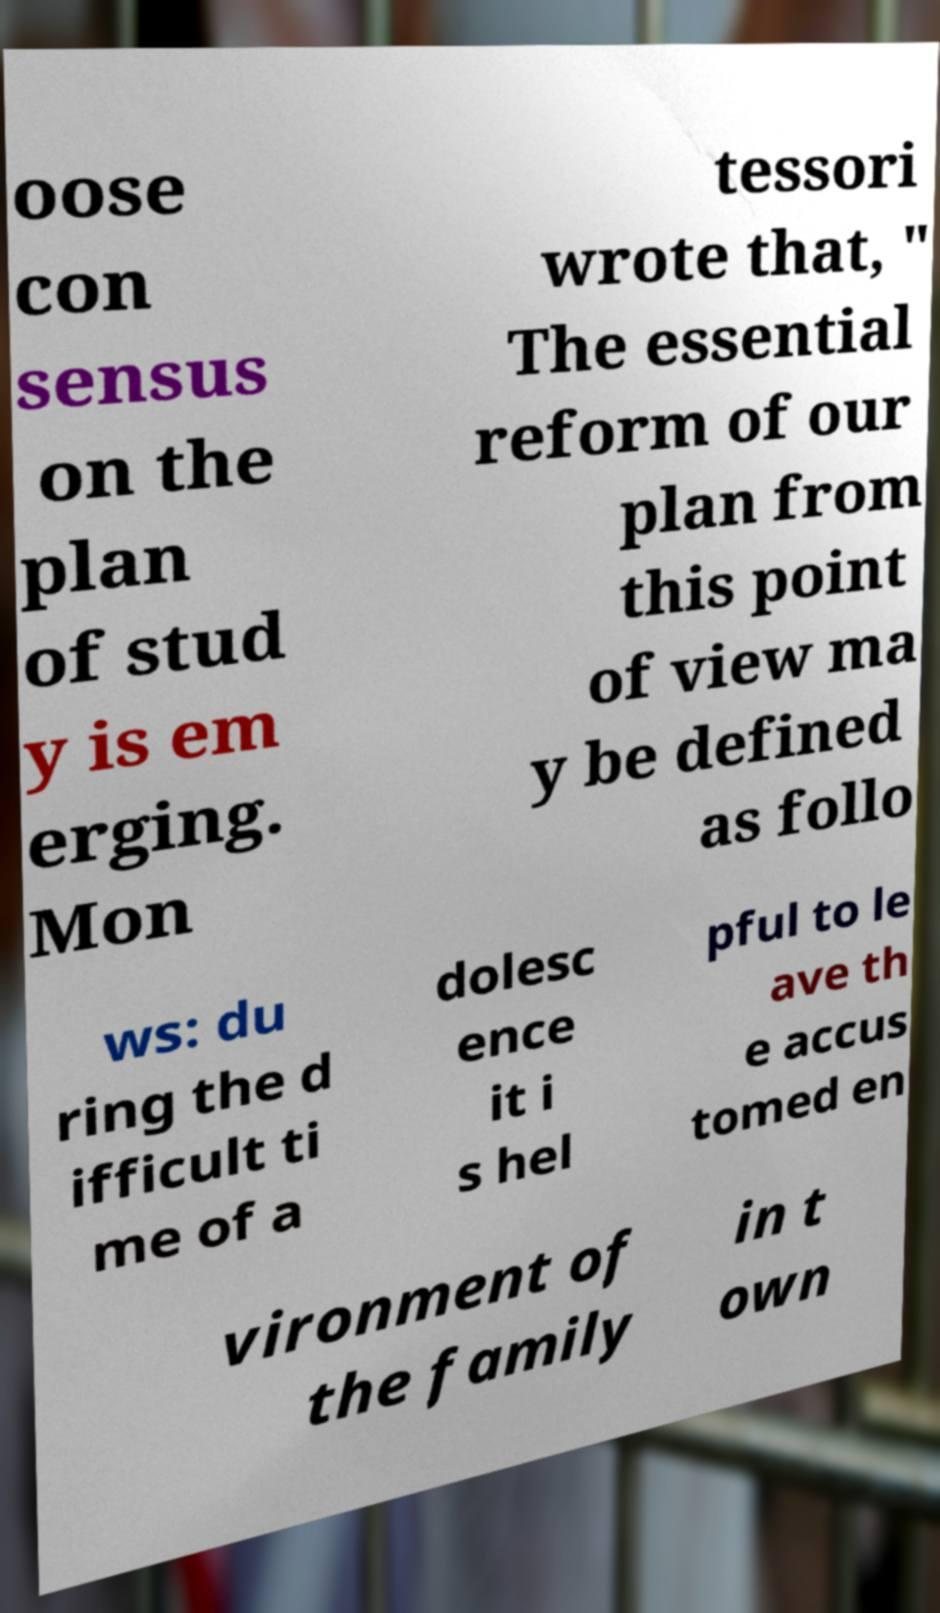Could you extract and type out the text from this image? oose con sensus on the plan of stud y is em erging. Mon tessori wrote that, " The essential reform of our plan from this point of view ma y be defined as follo ws: du ring the d ifficult ti me of a dolesc ence it i s hel pful to le ave th e accus tomed en vironment of the family in t own 